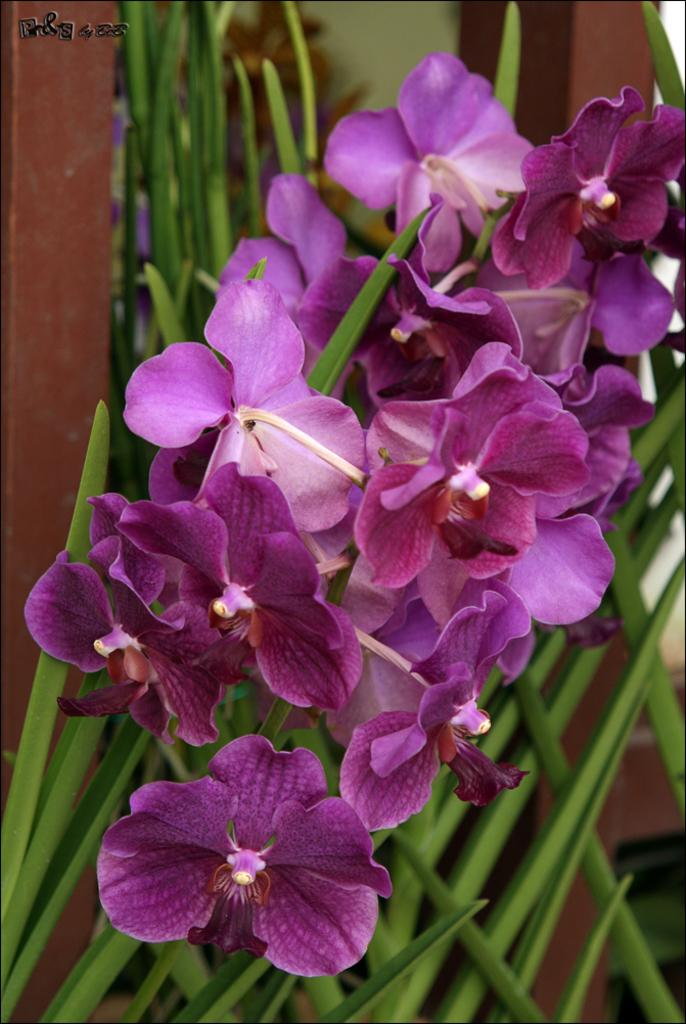What type of flowers can be seen in the image? There are purple color flowers in the image. What can be seen in the background of the image? There is greenery and two wooden pillars in the background of the image. Is there any text or marking in the image? Yes, there is a watermark in the left top of the image. Can you hear the bell ringing in the image? There is no bell present in the image, so it cannot be heard. 